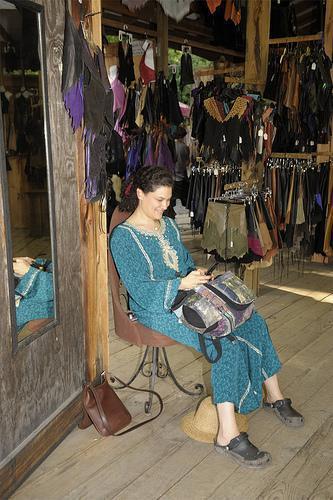How many mirrors can be seen?
Give a very brief answer. 1. 